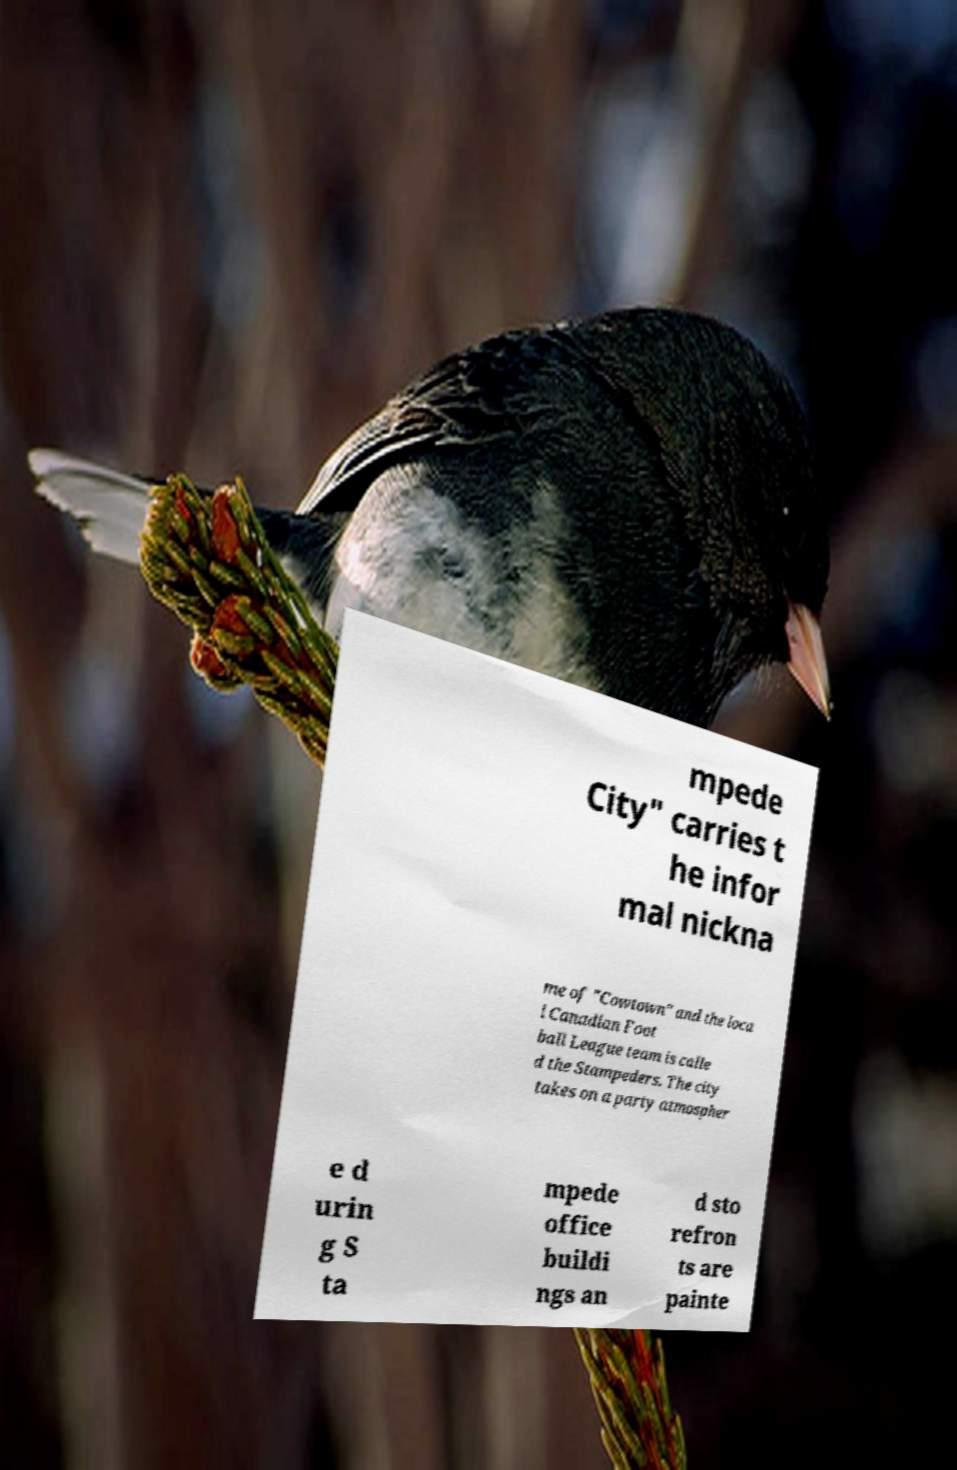Please identify and transcribe the text found in this image. mpede City" carries t he infor mal nickna me of "Cowtown" and the loca l Canadian Foot ball League team is calle d the Stampeders. The city takes on a party atmospher e d urin g S ta mpede office buildi ngs an d sto refron ts are painte 